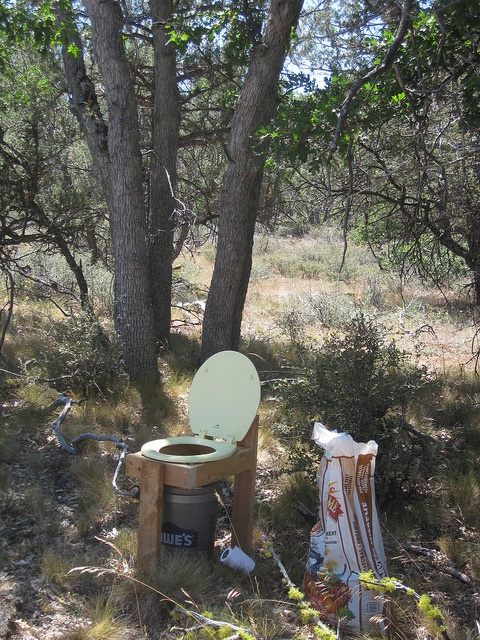Describe the objects in this image and their specific colors. I can see a toilet in gray, lightgray, darkgray, and ivory tones in this image. 